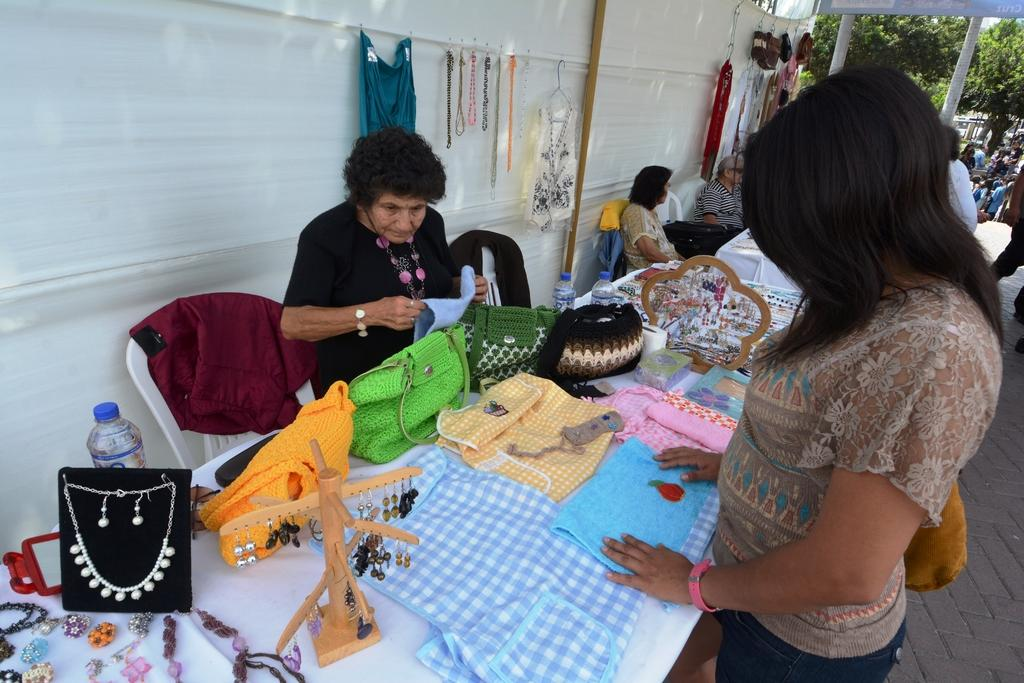What is one of the objects visible in the image? There is a bottle in the image. What else can be seen on the table in the image? There are clothes, jewelry, and other objects on the table in the image. Can you describe the people in the image? There are two women standing in the image, one of whom is wearing a bag. What type of furniture is present in the image? There are chairs in the image. What can be seen in the background of the image? There are trees in the image. What type of nut is being used as a representative for the group in the image? There is no nut present in the image, nor is there any indication of a representative for a group. 